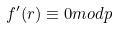<formula> <loc_0><loc_0><loc_500><loc_500>f ^ { \prime } ( r ) \equiv 0 m o d p</formula> 